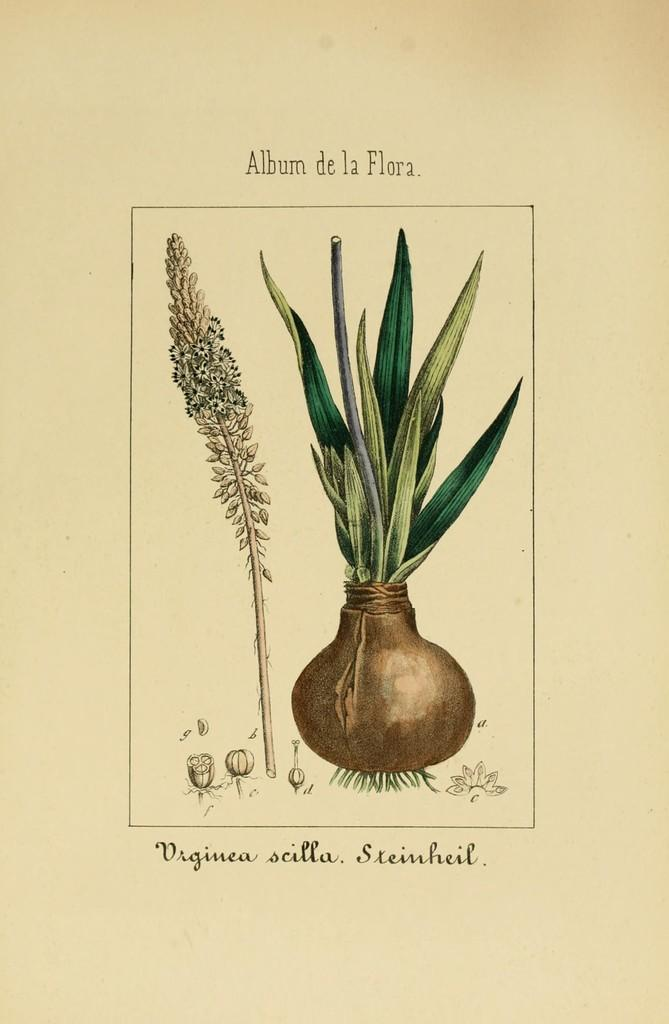What is the main subject of the picture? The main subject of the picture is an onion. What can be observed about the onion in the image? The onion has leaves. Are there any other leaves visible in the image? Yes, there is another leaf at the left side of the image. What is written in the image? There is text written at the top and bottom of the image. Reasoning: Let's think step by breaking down the conversation step by step. We start by identifying the main subject of the image, which is the onion. Then, we describe the onion's features, specifically mentioning the leaves. Next, we acknowledge the presence of another leaf in the image. Finally, we mention the text written in the image, which is located at both the top and bottom. Absurd Question/Answer: What type of record is being played on the brass instrument in the image? There is no record or brass instrument present in the image; it features an onion and leaves. What organization is responsible for the onion's growth in the image? The image does not provide information about the organization responsible for the onion's growth. 